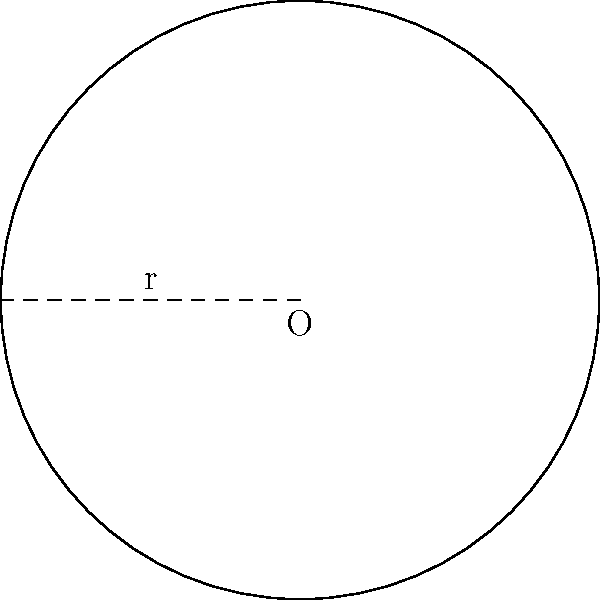As a visionary producer, you're designing a circular stage for Baby Lu's breakthrough performance. If the radius of the stage is 10 meters, what would be the total area of the stage in square meters? Express your answer in terms of π. To find the area of a circular stage, we need to follow these steps:

1. Recall the formula for the area of a circle:
   $$A = \pi r^2$$
   where A is the area and r is the radius.

2. We're given that the radius is 10 meters, so let's substitute this into our formula:
   $$A = \pi (10)^2$$

3. Simplify the expression:
   $$A = \pi \cdot 100$$

4. This simplifies to:
   $$A = 100\pi$$

Therefore, the area of the circular stage is $100\pi$ square meters.
Answer: $100\pi$ m² 